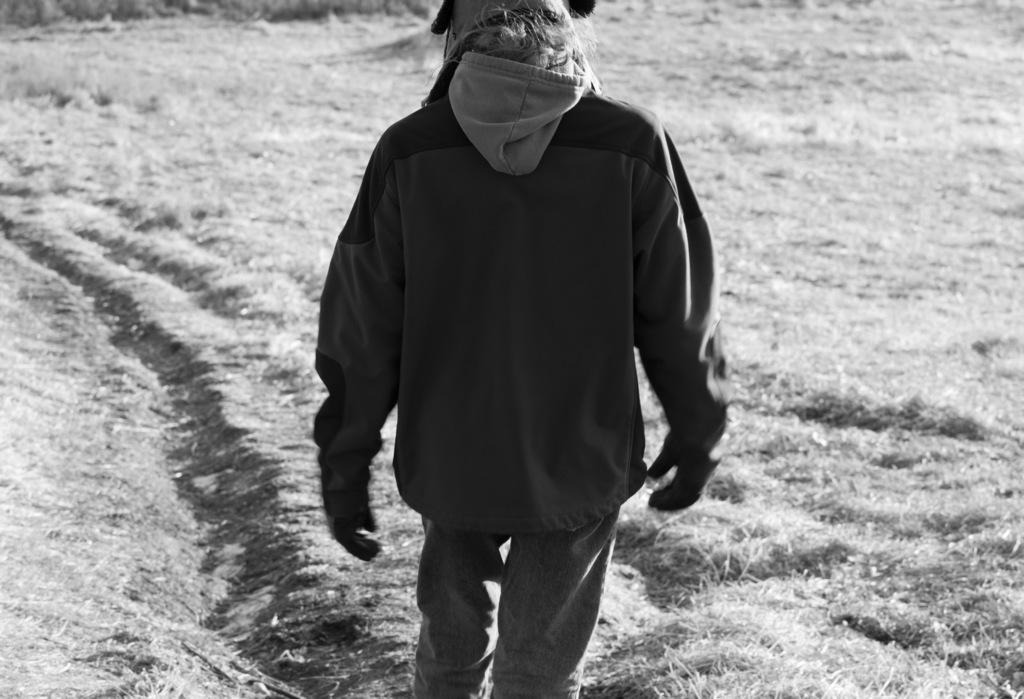Who or what is present in the image? There is a person in the image. What type of terrain can be seen in the image? There is dry grass in the image. What color scheme is used in the image? The image is in black and white. Where is the dock located in the image? There is no dock present in the image. What type of bed is visible in the image? There is no bed present in the image. 